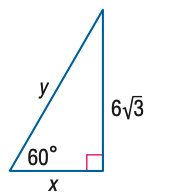Answer the mathemtical geometry problem and directly provide the correct option letter.
Question: Find y.
Choices: A: 6 B: 12 C: 6 \sqrt { 6 } D: 12 \sqrt { 3 } B 